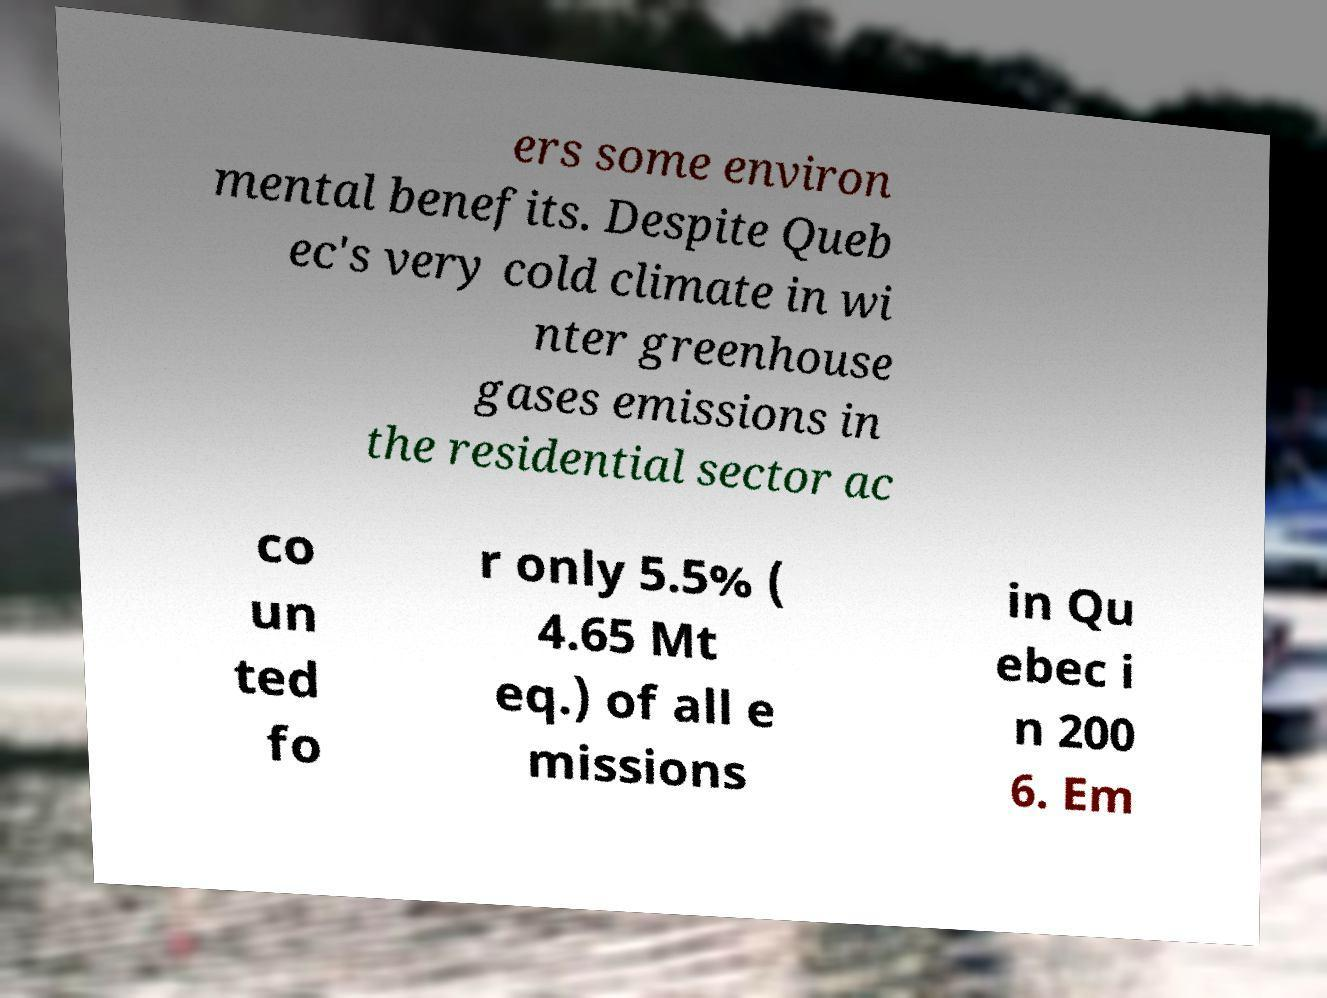Can you read and provide the text displayed in the image?This photo seems to have some interesting text. Can you extract and type it out for me? ers some environ mental benefits. Despite Queb ec's very cold climate in wi nter greenhouse gases emissions in the residential sector ac co un ted fo r only 5.5% ( 4.65 Mt eq.) of all e missions in Qu ebec i n 200 6. Em 